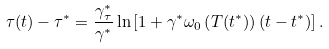<formula> <loc_0><loc_0><loc_500><loc_500>\tau ( t ) - \tau ^ { * } = \frac { \gamma _ { \tau } ^ { * } } { \gamma ^ { * } } \ln \left [ 1 + \gamma ^ { * } \omega _ { 0 } \left ( T ( t ^ { * } ) \right ) \left ( t - t ^ { * } \right ) \right ] .</formula> 